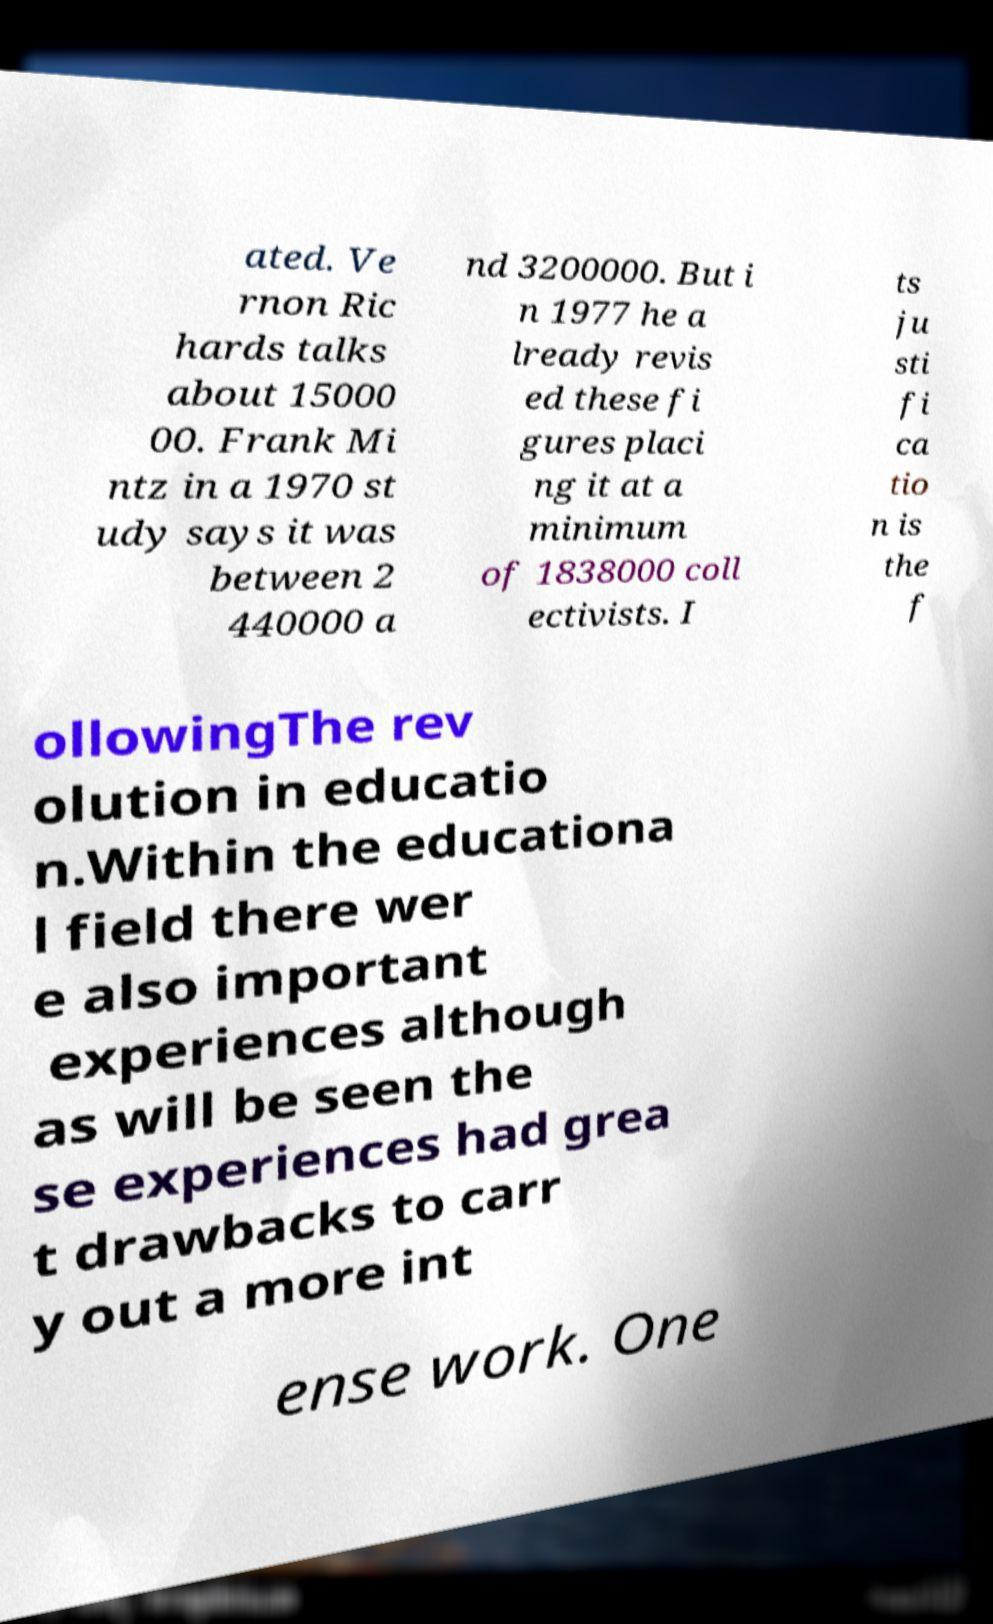For documentation purposes, I need the text within this image transcribed. Could you provide that? ated. Ve rnon Ric hards talks about 15000 00. Frank Mi ntz in a 1970 st udy says it was between 2 440000 a nd 3200000. But i n 1977 he a lready revis ed these fi gures placi ng it at a minimum of 1838000 coll ectivists. I ts ju sti fi ca tio n is the f ollowingThe rev olution in educatio n.Within the educationa l field there wer e also important experiences although as will be seen the se experiences had grea t drawbacks to carr y out a more int ense work. One 